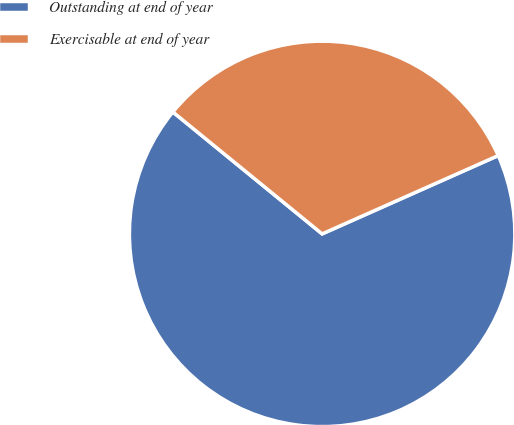<chart> <loc_0><loc_0><loc_500><loc_500><pie_chart><fcel>Outstanding at end of year<fcel>Exercisable at end of year<nl><fcel>67.56%<fcel>32.44%<nl></chart> 